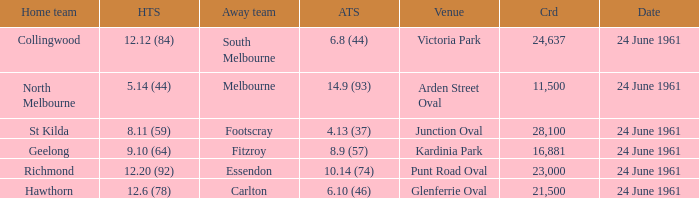What is the date of the game where the home team scored 9.10 (64)? 24 June 1961. 